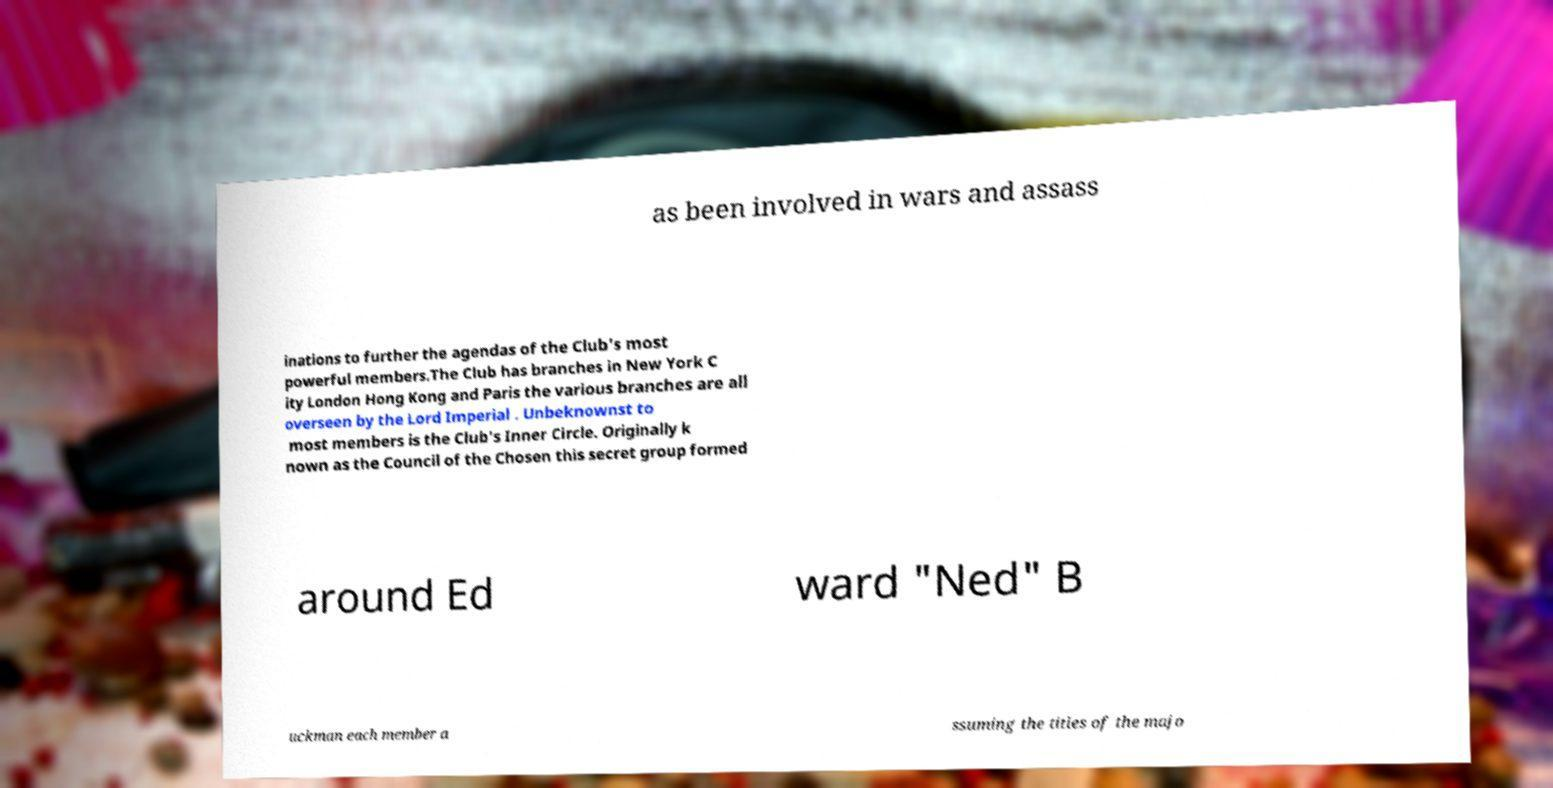Could you extract and type out the text from this image? as been involved in wars and assass inations to further the agendas of the Club's most powerful members.The Club has branches in New York C ity London Hong Kong and Paris the various branches are all overseen by the Lord Imperial . Unbeknownst to most members is the Club's Inner Circle. Originally k nown as the Council of the Chosen this secret group formed around Ed ward "Ned" B uckman each member a ssuming the titles of the majo 